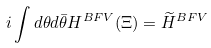Convert formula to latex. <formula><loc_0><loc_0><loc_500><loc_500>i \int d \theta d \bar { \theta } H ^ { B F V } ( \Xi ) = \widetilde { H } ^ { B F V }</formula> 